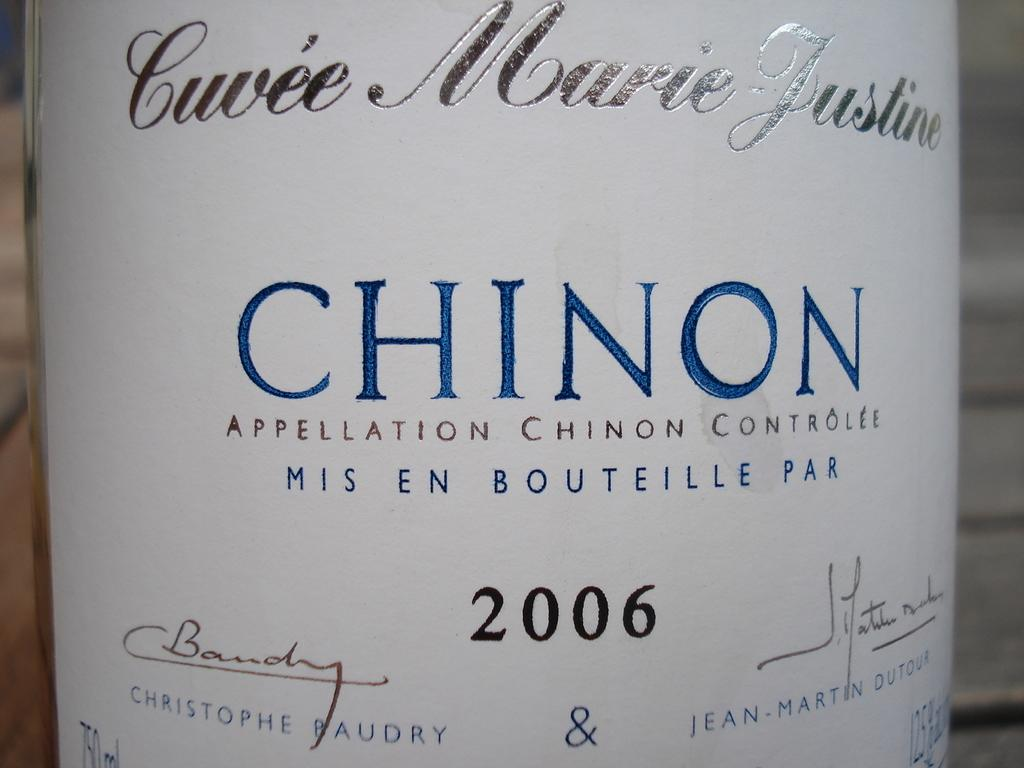Provide a one-sentence caption for the provided image. A white label with blue text reads "Chinon.". 